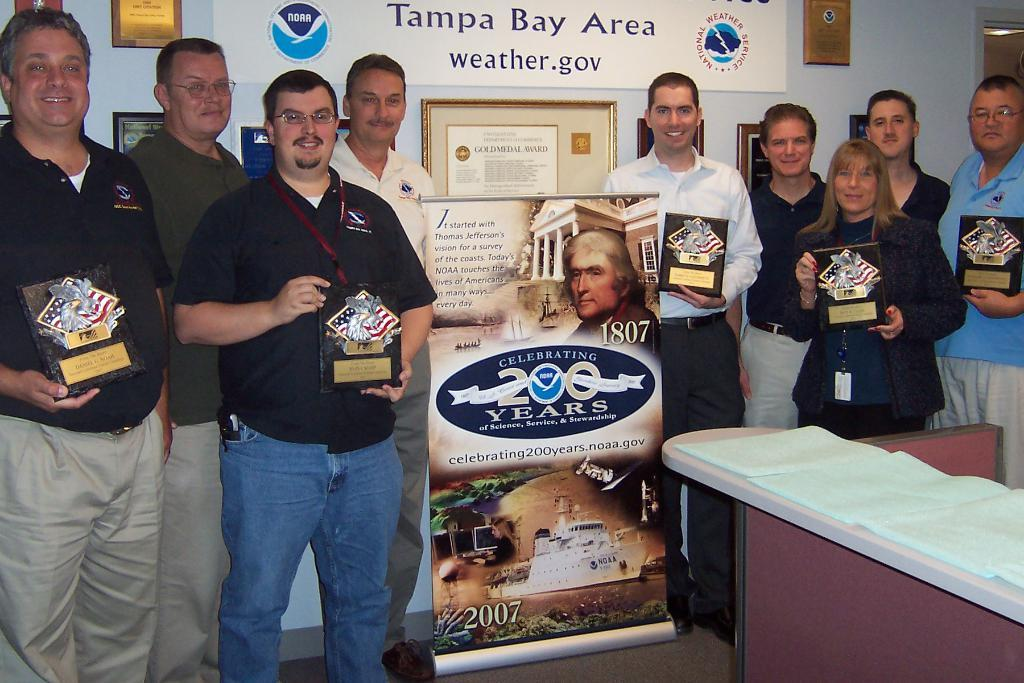<image>
Relay a brief, clear account of the picture shown. A group of people standing under a Tampa Bay Area banner. 